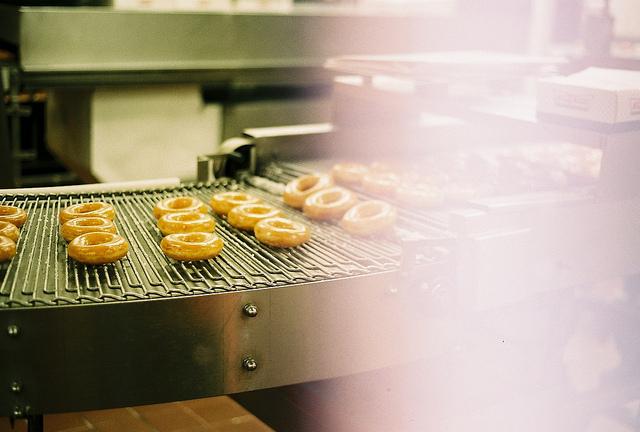How many donuts are there?
Write a very short answer. 18. What are these items called?
Answer briefly. Donuts. What are on the belt?
Quick response, please. Donuts. 